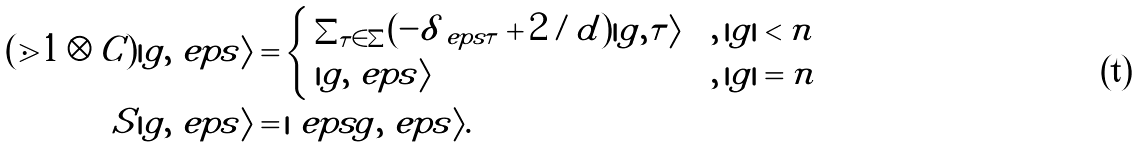<formula> <loc_0><loc_0><loc_500><loc_500>( \mathbb { m } { 1 } \otimes C ) | g , \ e p s \rangle = & \begin{cases} \, \sum _ { \tau \in \Sigma } ( - \delta _ { \ e p s \tau } + 2 / d ) | g , \tau \rangle & , \, | g | < n \\ \, | g , \ e p s \rangle & , \, | g | = n \end{cases} \\ S | g , \ e p s \rangle = & \, | \ e p s g , \ e p s \rangle .</formula> 